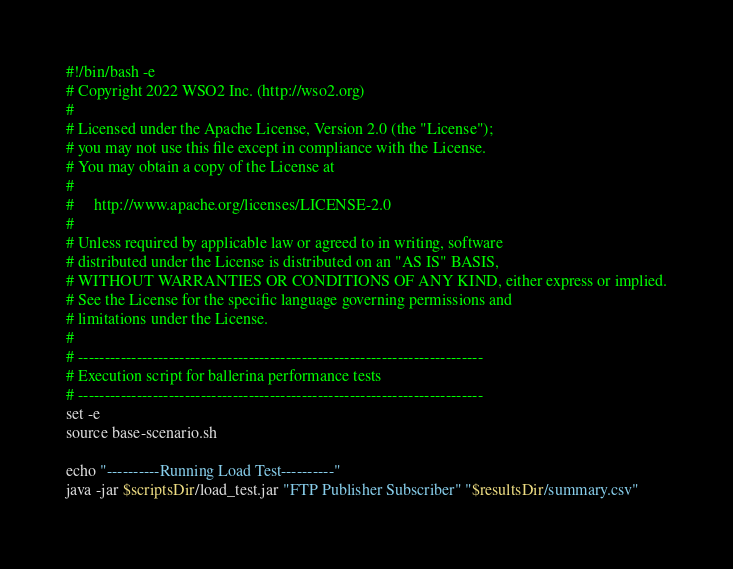<code> <loc_0><loc_0><loc_500><loc_500><_Bash_>#!/bin/bash -e
# Copyright 2022 WSO2 Inc. (http://wso2.org)
#
# Licensed under the Apache License, Version 2.0 (the "License");
# you may not use this file except in compliance with the License.
# You may obtain a copy of the License at
#
#     http://www.apache.org/licenses/LICENSE-2.0
#
# Unless required by applicable law or agreed to in writing, software
# distributed under the License is distributed on an "AS IS" BASIS,
# WITHOUT WARRANTIES OR CONDITIONS OF ANY KIND, either express or implied.
# See the License for the specific language governing permissions and
# limitations under the License.
#
# ----------------------------------------------------------------------------
# Execution script for ballerina performance tests
# ----------------------------------------------------------------------------
set -e
source base-scenario.sh

echo "----------Running Load Test----------"
java -jar $scriptsDir/load_test.jar "FTP Publisher Subscriber" "$resultsDir/summary.csv"
</code> 